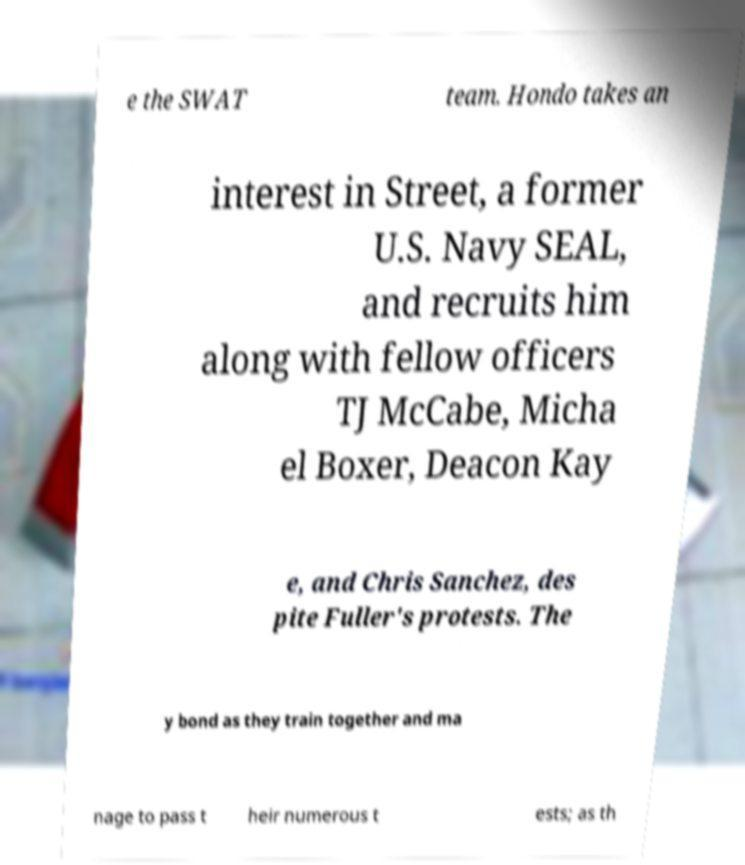Please read and relay the text visible in this image. What does it say? e the SWAT team. Hondo takes an interest in Street, a former U.S. Navy SEAL, and recruits him along with fellow officers TJ McCabe, Micha el Boxer, Deacon Kay e, and Chris Sanchez, des pite Fuller's protests. The y bond as they train together and ma nage to pass t heir numerous t ests; as th 